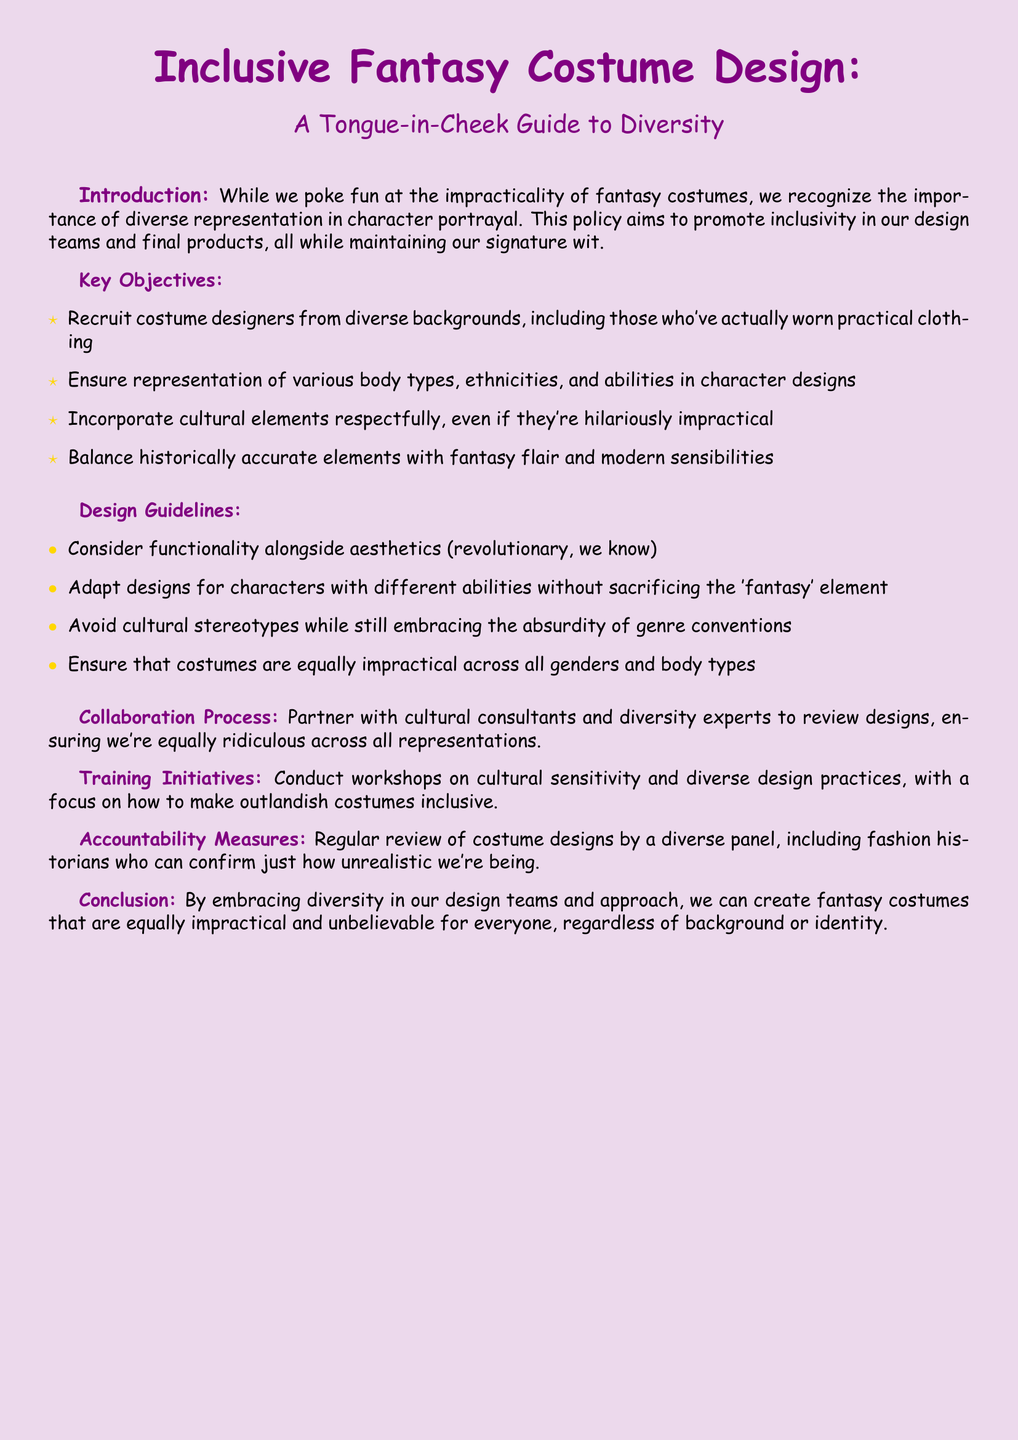What are the key objectives of the diversity policy? The key objectives are listed in the document under the Key Objectives section, which includes recruiting diverse costume designers and ensuring representation in character designs.
Answer: Recruit costume designers from diverse backgrounds, ensure representation of various body types, ethnicities, and abilities, incorporate cultural elements respectfully, balance historical accuracy with fantasy flair What colors are used in the title? The title text is presented in two colors as specified in the document, fantasy purple and fantasy gold.
Answer: Fantasy Purple and Fantasy Gold How should designs be adapted for characters with different abilities? The document mentions adaptations for characters with different abilities without sacrificing the fantasy element.
Answer: Without sacrificing the 'fantasy' element What is the purpose of partnership with cultural consultants? The document states that cultural consultants are to review designs to ensure appropriate representation and avoid stereotypes.
Answer: To ensure we're equally ridiculous across all representations What is the focus of the training initiatives? The training initiatives focus on cultural sensitivity and practices regarding diverse costume design to maintain inclusivity.
Answer: Cultural sensitivity and diverse design practices What is expected from the accountability measures? The document outlines that regular reviews of costume designs will occur from a diverse panel which adds oversight to the design process.
Answer: Regular review of costume designs by a diverse panel What humor style does the policy document embrace? The document integrates humor to address the impracticality of fantasy costumes while discussing serious topics of diversity and inclusion.
Answer: Tongue-in-cheek humor What is the final aim of embracing diversity in costume design teams? The conclusion states that embracing diversity allows for the creation of equally impractical costumes for everyone.
Answer: Create fantasy costumes that are equally impractical and unbelievable for everyone 